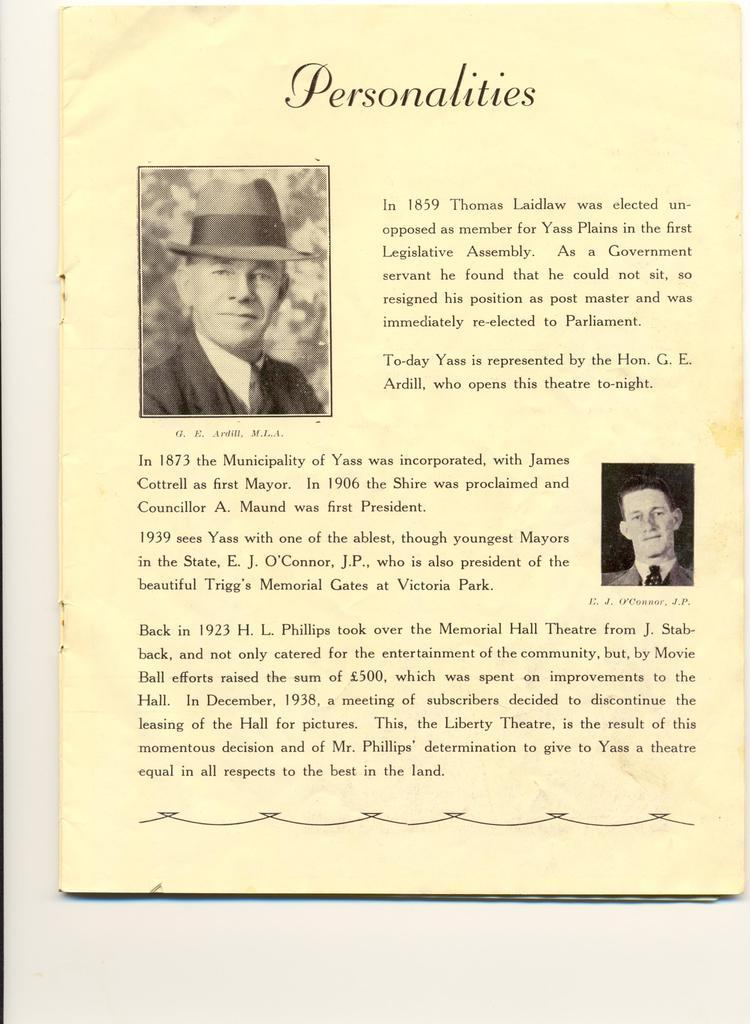What is present on the white surface in the image? There is a paper on the white surface in the image. What can be found on the paper? The paper has printed text and images of two persons on it. How does the steel affect the paper in the image? There is no steel present in the image, so it cannot affect the paper. 